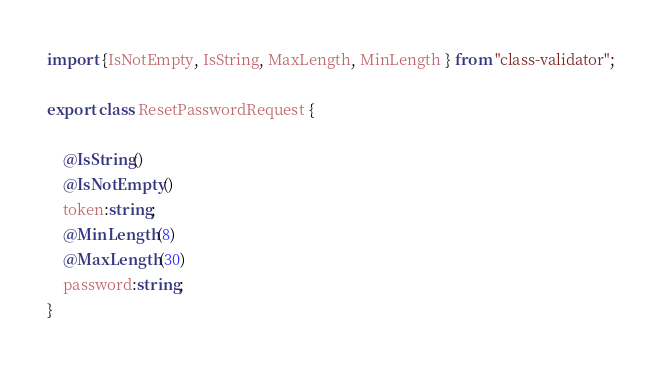Convert code to text. <code><loc_0><loc_0><loc_500><loc_500><_TypeScript_>import {IsNotEmpty, IsString, MaxLength, MinLength } from "class-validator";

export class ResetPasswordRequest {
    
    @IsString()
    @IsNotEmpty()
    token:string;
    @MinLength(8)
    @MaxLength(30)
    password:string;
}
</code> 